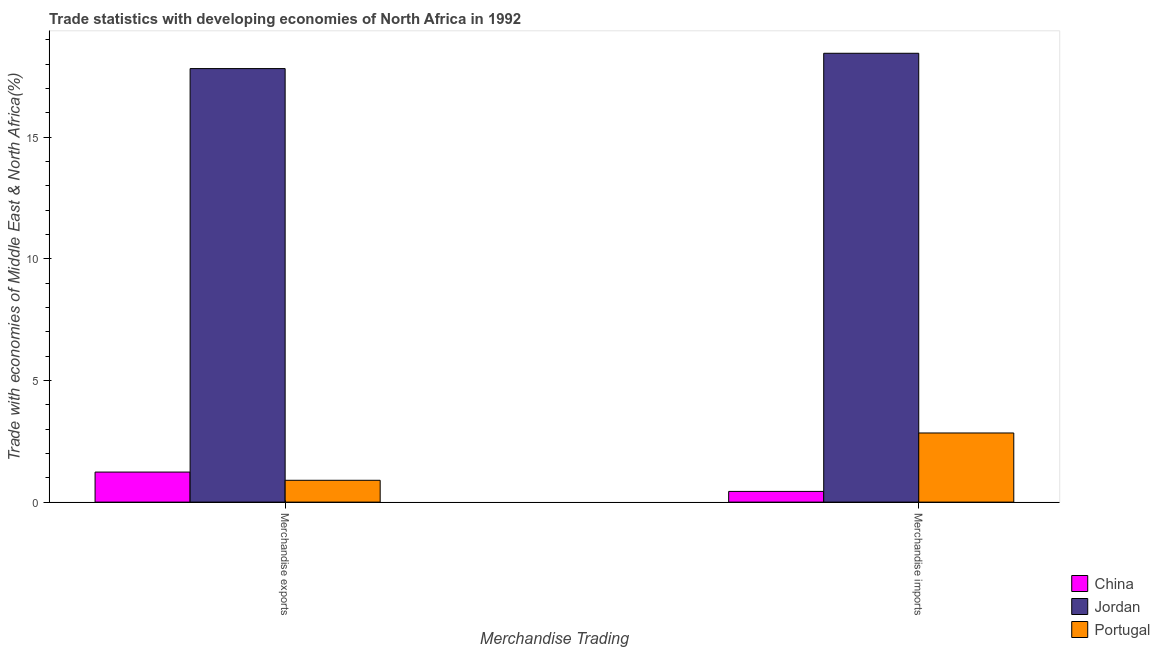How many different coloured bars are there?
Keep it short and to the point. 3. How many groups of bars are there?
Provide a succinct answer. 2. Are the number of bars on each tick of the X-axis equal?
Provide a succinct answer. Yes. What is the label of the 2nd group of bars from the left?
Your response must be concise. Merchandise imports. What is the merchandise imports in China?
Keep it short and to the point. 0.44. Across all countries, what is the maximum merchandise imports?
Make the answer very short. 18.45. Across all countries, what is the minimum merchandise imports?
Provide a succinct answer. 0.44. In which country was the merchandise exports maximum?
Make the answer very short. Jordan. What is the total merchandise exports in the graph?
Keep it short and to the point. 19.96. What is the difference between the merchandise imports in China and that in Portugal?
Make the answer very short. -2.4. What is the difference between the merchandise imports in China and the merchandise exports in Portugal?
Keep it short and to the point. -0.46. What is the average merchandise imports per country?
Offer a terse response. 7.25. What is the difference between the merchandise imports and merchandise exports in China?
Offer a terse response. -0.8. In how many countries, is the merchandise imports greater than 13 %?
Offer a terse response. 1. What is the ratio of the merchandise imports in China to that in Portugal?
Your response must be concise. 0.15. Is the merchandise exports in Jordan less than that in China?
Your answer should be very brief. No. In how many countries, is the merchandise exports greater than the average merchandise exports taken over all countries?
Provide a short and direct response. 1. What does the 2nd bar from the left in Merchandise imports represents?
Your answer should be very brief. Jordan. What does the 3rd bar from the right in Merchandise imports represents?
Offer a very short reply. China. Are the values on the major ticks of Y-axis written in scientific E-notation?
Offer a terse response. No. Does the graph contain any zero values?
Give a very brief answer. No. Where does the legend appear in the graph?
Ensure brevity in your answer.  Bottom right. How many legend labels are there?
Keep it short and to the point. 3. What is the title of the graph?
Ensure brevity in your answer.  Trade statistics with developing economies of North Africa in 1992. What is the label or title of the X-axis?
Your answer should be very brief. Merchandise Trading. What is the label or title of the Y-axis?
Your response must be concise. Trade with economies of Middle East & North Africa(%). What is the Trade with economies of Middle East & North Africa(%) of China in Merchandise exports?
Keep it short and to the point. 1.24. What is the Trade with economies of Middle East & North Africa(%) of Jordan in Merchandise exports?
Your answer should be very brief. 17.82. What is the Trade with economies of Middle East & North Africa(%) in Portugal in Merchandise exports?
Keep it short and to the point. 0.9. What is the Trade with economies of Middle East & North Africa(%) in China in Merchandise imports?
Keep it short and to the point. 0.44. What is the Trade with economies of Middle East & North Africa(%) in Jordan in Merchandise imports?
Your answer should be very brief. 18.45. What is the Trade with economies of Middle East & North Africa(%) in Portugal in Merchandise imports?
Give a very brief answer. 2.84. Across all Merchandise Trading, what is the maximum Trade with economies of Middle East & North Africa(%) in China?
Provide a succinct answer. 1.24. Across all Merchandise Trading, what is the maximum Trade with economies of Middle East & North Africa(%) of Jordan?
Provide a succinct answer. 18.45. Across all Merchandise Trading, what is the maximum Trade with economies of Middle East & North Africa(%) in Portugal?
Your answer should be compact. 2.84. Across all Merchandise Trading, what is the minimum Trade with economies of Middle East & North Africa(%) of China?
Provide a succinct answer. 0.44. Across all Merchandise Trading, what is the minimum Trade with economies of Middle East & North Africa(%) in Jordan?
Provide a short and direct response. 17.82. Across all Merchandise Trading, what is the minimum Trade with economies of Middle East & North Africa(%) of Portugal?
Your response must be concise. 0.9. What is the total Trade with economies of Middle East & North Africa(%) in China in the graph?
Offer a terse response. 1.68. What is the total Trade with economies of Middle East & North Africa(%) of Jordan in the graph?
Give a very brief answer. 36.28. What is the total Trade with economies of Middle East & North Africa(%) in Portugal in the graph?
Offer a very short reply. 3.74. What is the difference between the Trade with economies of Middle East & North Africa(%) in China in Merchandise exports and that in Merchandise imports?
Keep it short and to the point. 0.8. What is the difference between the Trade with economies of Middle East & North Africa(%) in Jordan in Merchandise exports and that in Merchandise imports?
Keep it short and to the point. -0.63. What is the difference between the Trade with economies of Middle East & North Africa(%) of Portugal in Merchandise exports and that in Merchandise imports?
Provide a short and direct response. -1.94. What is the difference between the Trade with economies of Middle East & North Africa(%) of China in Merchandise exports and the Trade with economies of Middle East & North Africa(%) of Jordan in Merchandise imports?
Keep it short and to the point. -17.22. What is the difference between the Trade with economies of Middle East & North Africa(%) of China in Merchandise exports and the Trade with economies of Middle East & North Africa(%) of Portugal in Merchandise imports?
Ensure brevity in your answer.  -1.61. What is the difference between the Trade with economies of Middle East & North Africa(%) of Jordan in Merchandise exports and the Trade with economies of Middle East & North Africa(%) of Portugal in Merchandise imports?
Ensure brevity in your answer.  14.98. What is the average Trade with economies of Middle East & North Africa(%) in China per Merchandise Trading?
Give a very brief answer. 0.84. What is the average Trade with economies of Middle East & North Africa(%) of Jordan per Merchandise Trading?
Ensure brevity in your answer.  18.14. What is the average Trade with economies of Middle East & North Africa(%) in Portugal per Merchandise Trading?
Make the answer very short. 1.87. What is the difference between the Trade with economies of Middle East & North Africa(%) of China and Trade with economies of Middle East & North Africa(%) of Jordan in Merchandise exports?
Provide a succinct answer. -16.59. What is the difference between the Trade with economies of Middle East & North Africa(%) of China and Trade with economies of Middle East & North Africa(%) of Portugal in Merchandise exports?
Give a very brief answer. 0.34. What is the difference between the Trade with economies of Middle East & North Africa(%) in Jordan and Trade with economies of Middle East & North Africa(%) in Portugal in Merchandise exports?
Ensure brevity in your answer.  16.93. What is the difference between the Trade with economies of Middle East & North Africa(%) in China and Trade with economies of Middle East & North Africa(%) in Jordan in Merchandise imports?
Offer a terse response. -18.01. What is the difference between the Trade with economies of Middle East & North Africa(%) of China and Trade with economies of Middle East & North Africa(%) of Portugal in Merchandise imports?
Your answer should be compact. -2.4. What is the difference between the Trade with economies of Middle East & North Africa(%) in Jordan and Trade with economies of Middle East & North Africa(%) in Portugal in Merchandise imports?
Keep it short and to the point. 15.61. What is the ratio of the Trade with economies of Middle East & North Africa(%) in China in Merchandise exports to that in Merchandise imports?
Make the answer very short. 2.81. What is the ratio of the Trade with economies of Middle East & North Africa(%) in Jordan in Merchandise exports to that in Merchandise imports?
Offer a very short reply. 0.97. What is the ratio of the Trade with economies of Middle East & North Africa(%) in Portugal in Merchandise exports to that in Merchandise imports?
Make the answer very short. 0.32. What is the difference between the highest and the second highest Trade with economies of Middle East & North Africa(%) in China?
Offer a very short reply. 0.8. What is the difference between the highest and the second highest Trade with economies of Middle East & North Africa(%) of Jordan?
Offer a terse response. 0.63. What is the difference between the highest and the second highest Trade with economies of Middle East & North Africa(%) in Portugal?
Offer a very short reply. 1.94. What is the difference between the highest and the lowest Trade with economies of Middle East & North Africa(%) in China?
Offer a terse response. 0.8. What is the difference between the highest and the lowest Trade with economies of Middle East & North Africa(%) of Jordan?
Ensure brevity in your answer.  0.63. What is the difference between the highest and the lowest Trade with economies of Middle East & North Africa(%) of Portugal?
Provide a succinct answer. 1.94. 